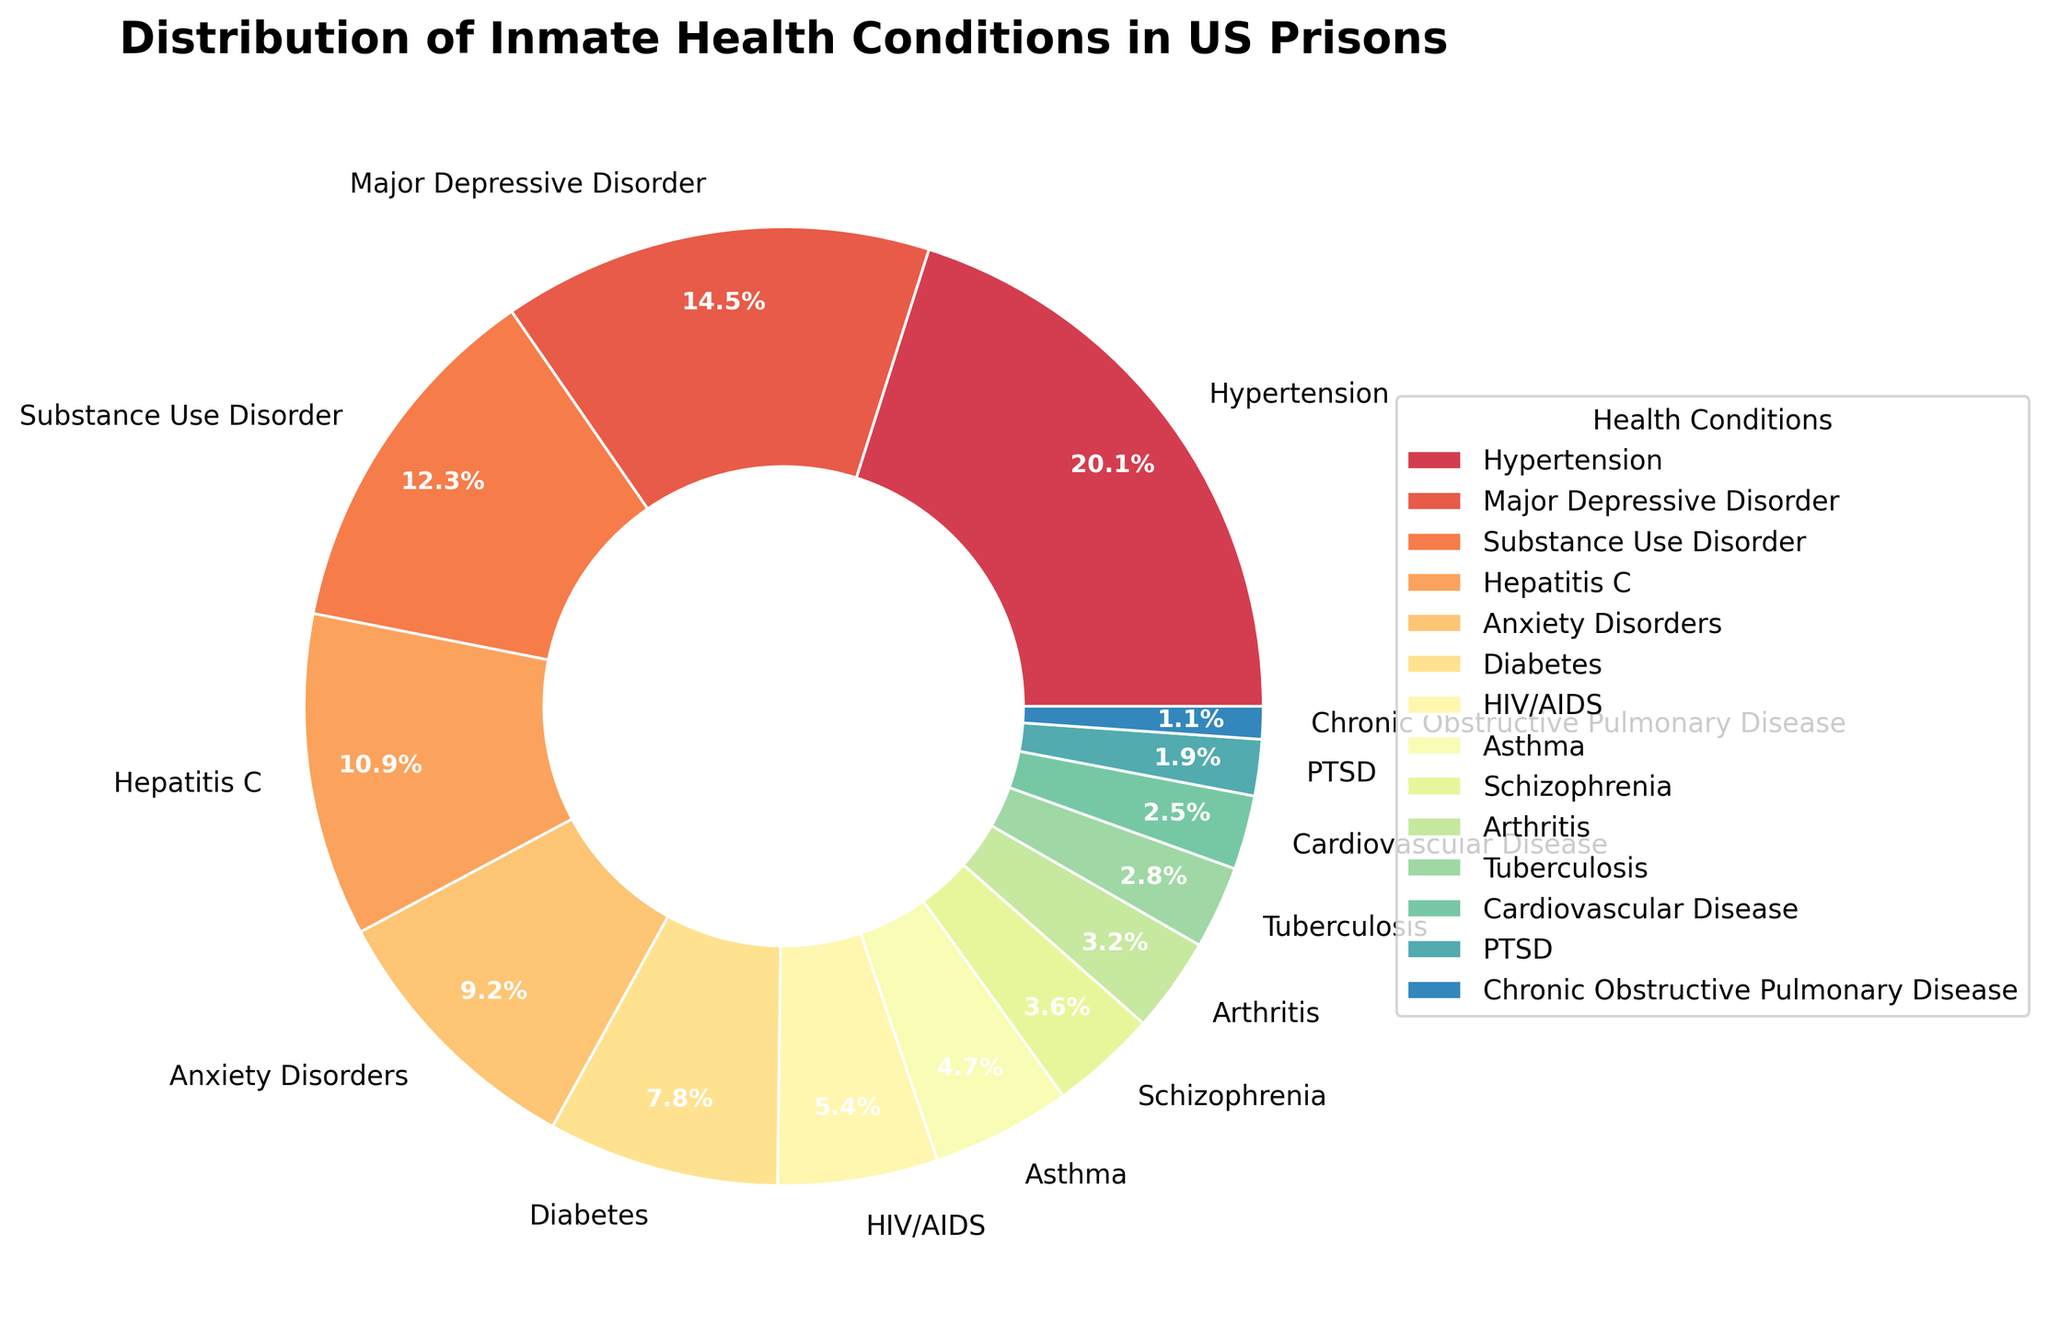What health condition has the highest percentage among inmates? Look at the pie chart and identify the health condition with the largest sector.
Answer: Hypertension What is the combined percentage of inmates with Major Depressive Disorder and Anxiety Disorders? Add the percentages for Major Depressive Disorder (14.5%) and Anxiety Disorders (9.2%) together. 14.5% + 9.2% = 23.7%
Answer: 23.7% Which health condition has a higher prevalence, Hepatitis C or HIV/AIDS? Compare the percentage sectors of Hepatitis C (10.9%) and HIV/AIDS (5.4%) in the pie chart.
Answer: Hepatitis C How much larger is the sector for Substance Use Disorder compared to the sector for PTSD? Subtract the percentage of PTSD (1.9%) from the percentage of Substance Use Disorder (12.3%). 12.3% - 1.9% = 10.4%
Answer: 10.4% Are there more inmates with Chronic Obstructive Pulmonary Disease or Tuberculosis? Compare the respective sectors of Chronic Obstructive Pulmonary Disease (1.1%) and Tuberculosis (2.8%) in the pie chart.
Answer: Tuberculosis What is the color associated with the wedge representing Schizophrenia? Identify the color of the wedge labeled "Schizophrenia" in the pie chart.
Answer: [Note: The answer will vary based on the specific plot generation, but for example, it might be "light blue."] Which health condition's sector is just above 10%? Look for the health condition whose sector falls just above the 10% mark in the pie chart.
Answer: Hepatitis C What is the relative difference in percentage between Asthma and Arthritis? Subtract the percentage of Arthritis (3.2%) from the percentage of Asthma (4.7%). 4.7% - 3.2% = 1.5%
Answer: 1.5% How many health conditions have a percentage greater than 10%? Count the sectors in the pie chart that represent conditions with percentages greater than 10%.
Answer: 3 What is the average percentage of inmates with Diabetes, Asthma, and Cardiovascular Disease? Add the percentages of Diabetes (7.8%), Asthma (4.7%), and Cardiovascular Disease (2.5%), then divide by 3. (7.8% + 4.7% + 2.5%) / 3 ≈ 5.0%
Answer: 5.0% 